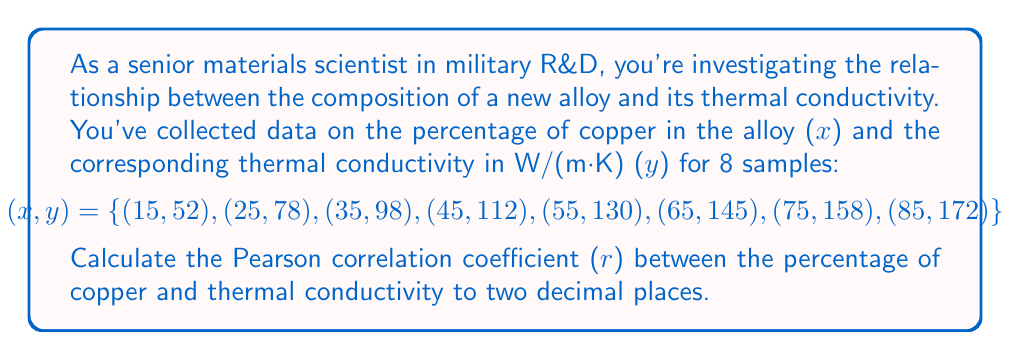Give your solution to this math problem. To calculate the Pearson correlation coefficient (r), we'll use the formula:

$$r = \frac{n\sum xy - \sum x \sum y}{\sqrt{[n\sum x^2 - (\sum x)^2][n\sum y^2 - (\sum y)^2]}}$$

Where:
n = number of samples
x = percentage of copper
y = thermal conductivity

Step 1: Calculate the required sums:
n = 8
$\sum x = 400$
$\sum y = 945$
$\sum xy = 54,550$
$\sum x^2 = 24,500$
$\sum y^2 = 121,509$

Step 2: Substitute these values into the formula:

$$r = \frac{8(54,550) - (400)(945)}{\sqrt{[8(24,500) - 400^2][8(121,509) - 945^2]}}$$

Step 3: Simplify:

$$r = \frac{436,400 - 378,000}{\sqrt{(196,000 - 160,000)(972,072 - 893,025)}}$$

$$r = \frac{58,400}{\sqrt{(36,000)(79,047)}}$$

$$r = \frac{58,400}{\sqrt{2,845,692,000}}$$

$$r = \frac{58,400}{53,344.65}$$

Step 4: Calculate the final result:

$$r \approx 1.0948$$

Step 5: Round to two decimal places:

$$r \approx 0.99$$
Answer: The Pearson correlation coefficient (r) between the percentage of copper and thermal conductivity is approximately 0.99. 